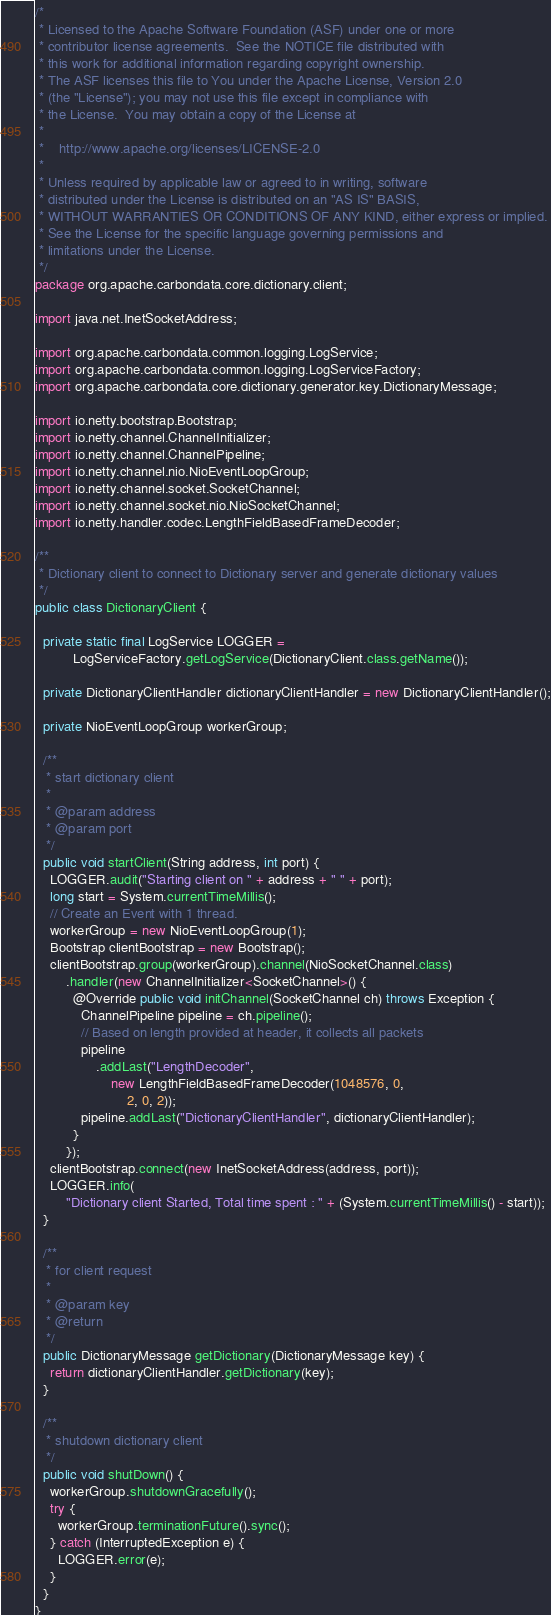<code> <loc_0><loc_0><loc_500><loc_500><_Java_>/*
 * Licensed to the Apache Software Foundation (ASF) under one or more
 * contributor license agreements.  See the NOTICE file distributed with
 * this work for additional information regarding copyright ownership.
 * The ASF licenses this file to You under the Apache License, Version 2.0
 * (the "License"); you may not use this file except in compliance with
 * the License.  You may obtain a copy of the License at
 *
 *    http://www.apache.org/licenses/LICENSE-2.0
 *
 * Unless required by applicable law or agreed to in writing, software
 * distributed under the License is distributed on an "AS IS" BASIS,
 * WITHOUT WARRANTIES OR CONDITIONS OF ANY KIND, either express or implied.
 * See the License for the specific language governing permissions and
 * limitations under the License.
 */
package org.apache.carbondata.core.dictionary.client;

import java.net.InetSocketAddress;

import org.apache.carbondata.common.logging.LogService;
import org.apache.carbondata.common.logging.LogServiceFactory;
import org.apache.carbondata.core.dictionary.generator.key.DictionaryMessage;

import io.netty.bootstrap.Bootstrap;
import io.netty.channel.ChannelInitializer;
import io.netty.channel.ChannelPipeline;
import io.netty.channel.nio.NioEventLoopGroup;
import io.netty.channel.socket.SocketChannel;
import io.netty.channel.socket.nio.NioSocketChannel;
import io.netty.handler.codec.LengthFieldBasedFrameDecoder;

/**
 * Dictionary client to connect to Dictionary server and generate dictionary values
 */
public class DictionaryClient {

  private static final LogService LOGGER =
          LogServiceFactory.getLogService(DictionaryClient.class.getName());

  private DictionaryClientHandler dictionaryClientHandler = new DictionaryClientHandler();

  private NioEventLoopGroup workerGroup;

  /**
   * start dictionary client
   *
   * @param address
   * @param port
   */
  public void startClient(String address, int port) {
    LOGGER.audit("Starting client on " + address + " " + port);
    long start = System.currentTimeMillis();
    // Create an Event with 1 thread.
    workerGroup = new NioEventLoopGroup(1);
    Bootstrap clientBootstrap = new Bootstrap();
    clientBootstrap.group(workerGroup).channel(NioSocketChannel.class)
        .handler(new ChannelInitializer<SocketChannel>() {
          @Override public void initChannel(SocketChannel ch) throws Exception {
            ChannelPipeline pipeline = ch.pipeline();
            // Based on length provided at header, it collects all packets
            pipeline
                .addLast("LengthDecoder",
                    new LengthFieldBasedFrameDecoder(1048576, 0,
                        2, 0, 2));
            pipeline.addLast("DictionaryClientHandler", dictionaryClientHandler);
          }
        });
    clientBootstrap.connect(new InetSocketAddress(address, port));
    LOGGER.info(
        "Dictionary client Started, Total time spent : " + (System.currentTimeMillis() - start));
  }

  /**
   * for client request
   *
   * @param key
   * @return
   */
  public DictionaryMessage getDictionary(DictionaryMessage key) {
    return dictionaryClientHandler.getDictionary(key);
  }

  /**
   * shutdown dictionary client
   */
  public void shutDown() {
    workerGroup.shutdownGracefully();
    try {
      workerGroup.terminationFuture().sync();
    } catch (InterruptedException e) {
      LOGGER.error(e);
    }
  }
}
</code> 